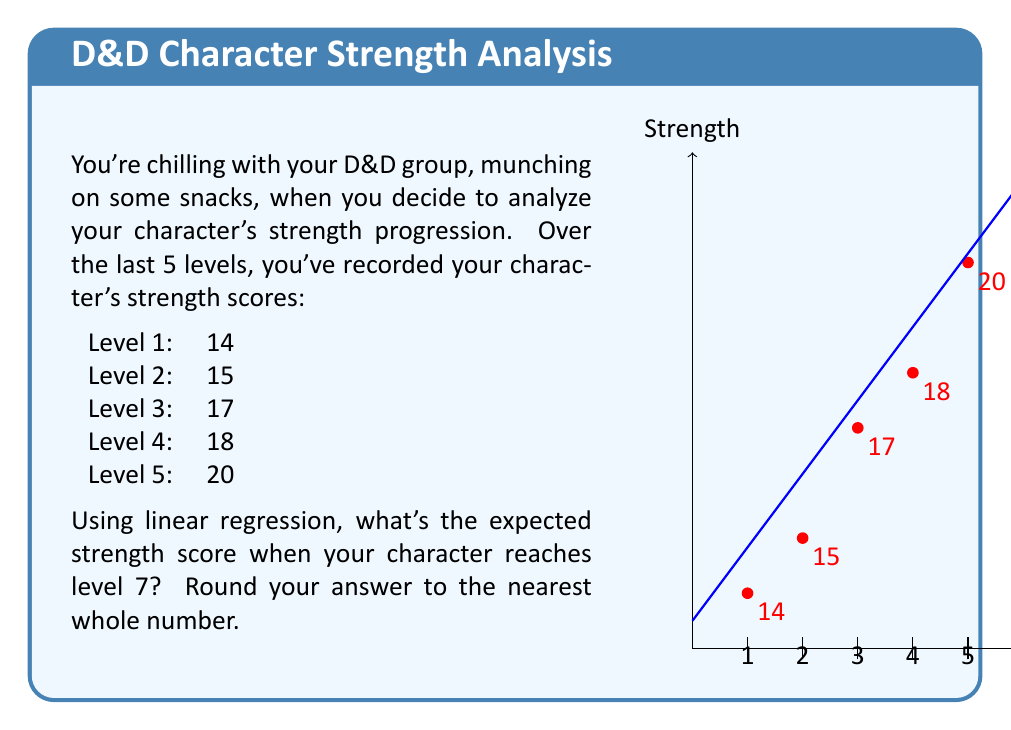Can you solve this math problem? Let's approach this step-by-step using linear regression:

1) First, we need to calculate the slope (m) and y-intercept (b) of the regression line.

2) The formula for the slope is:
   $$m = \frac{n\sum xy - \sum x \sum y}{n\sum x^2 - (\sum x)^2}$$

3) The formula for the y-intercept is:
   $$b = \frac{\sum y - m\sum x}{n}$$

4) Let's calculate the necessary sums:
   $\sum x = 1 + 2 + 3 + 4 + 5 = 15$
   $\sum y = 14 + 15 + 17 + 18 + 20 = 84$
   $\sum xy = 1(14) + 2(15) + 3(17) + 4(18) + 5(20) = 310$
   $\sum x^2 = 1^2 + 2^2 + 3^2 + 4^2 + 5^2 = 55$
   $n = 5$

5) Now, let's calculate the slope:
   $$m = \frac{5(310) - 15(84)}{5(55) - 15^2} = \frac{1550 - 1260}{275 - 225} = \frac{290}{50} = 1.5$$

6) And the y-intercept:
   $$b = \frac{84 - 1.5(15)}{5} = \frac{84 - 22.5}{5} = 12.3$$

7) Our regression line equation is:
   $$y = 1.5x + 12.3$$

8) To find the expected strength at level 7, we plug in x = 7:
   $$y = 1.5(7) + 12.3 = 10.5 + 12.3 = 22.8$$

9) Rounding to the nearest whole number, we get 23.
Answer: 23 